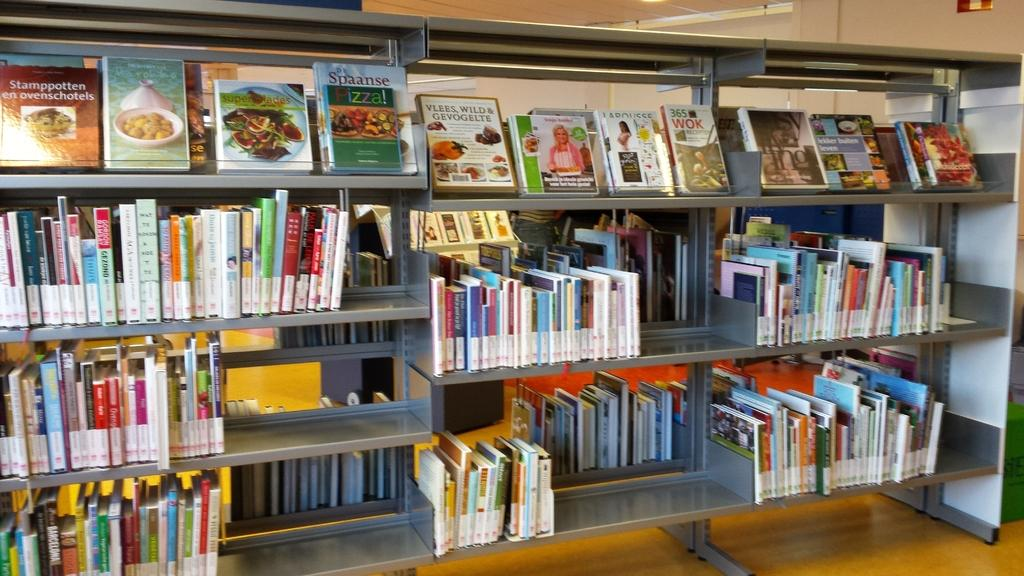Provide a one-sentence caption for the provided image. Shelves of books are on display with the upper left book titled Stamppotten en ovenschotels. 